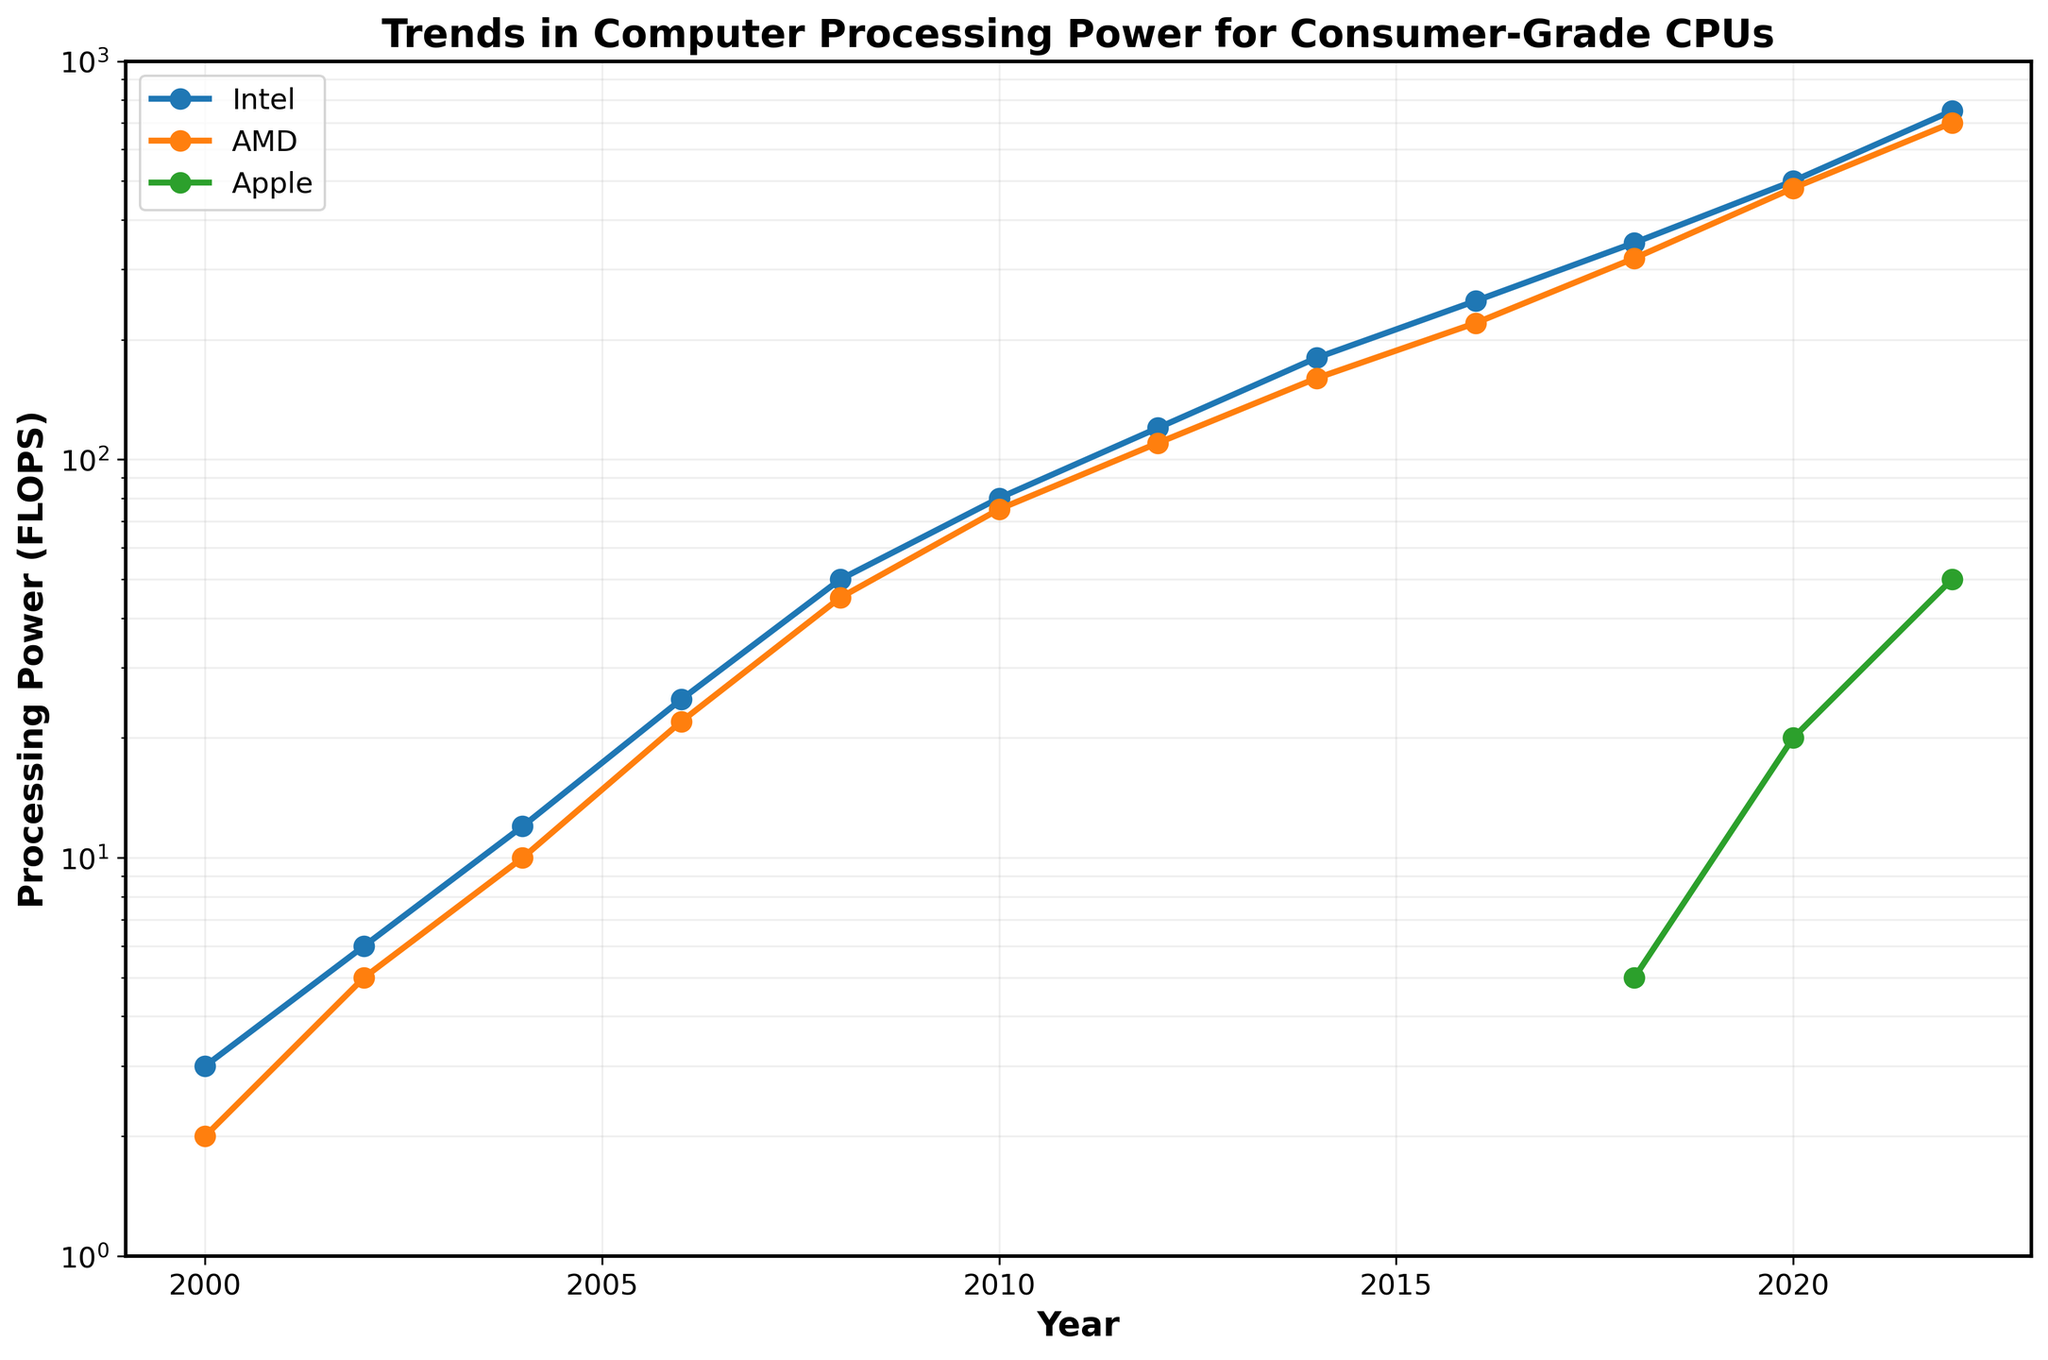What trend can be observed for Intel's processing power from 2000 to 2022? Intel's processing power shows a continuous, exponential increase over the years. Specifically, it starts at 3 FLOPS in 2000 and rises to 750 FLOPS in 2022. This indicates significant advancements in Intel's consumer-grade CPU performance over time.
Answer: Continuous exponential increase When did Apple first appear in the data, and what was its processing power at that time? Apple first appears in the data in 2018, with a processing power of 5 FLOPS. This is seen by looking at the data points plotted for Apple, which start appearing in 2018 on the line chart.
Answer: 2018, 5 FLOPS How does AMD's processing power in 2012 compare to Intel's and Apple's processing power in the same year? In 2012, AMD's processing power is 110 FLOPS, which is slightly lower than Intel's 120 FLOPS. Apple does not have data for 2012 as it only appears in the dataset from 2018 onwards.
Answer: AMD: 110 FLOPS, Intel: 120 FLOPS, Apple: N/A What is the difference in processing power between Intel and AMD in 2020? In 2020, Intel has a processing power of 500 FLOPS and AMD has 480 FLOPS. The difference is calculated by subtracting AMD's value from Intel's value, i.e., 500 - 480 = 20 FLOPS.
Answer: 20 FLOPS Between which years did AMD see the greatest increase in processing power? To find the greatest increase, we calculate the difference for each period. From 2018 to 2020, AMD's processing power increased from 320 to 480 FLOPS, the greatest jump of 160 FLOPS. Checking other years, no other period shows an increase as large as this.
Answer: 2018 to 2020 Compare the growth rate of processing power for Intel and Apple between 2018 and 2022. Intel's processing power grows from 350 FLOPS to 750 FLOPS, an increase of 400 FLOPS. Apple's processing power grows from 5 FLOPS to 50 FLOPS, an increase of 45 FLOPS. Intel's growth in this period is 750/350 ≈ 2.14 times (or approximately 114%), whereas Apple's growth is 50/5 = 10 times (or 900%). Thus, Apple's growth rate is significantly higher.
Answer: Apple's growth rate is significantly higher What does the grid pattern in the plot suggest about the y-axis scaling? The grid lines with varying spacings indicate that the y-axis is plotted on a logarithmic scale, which helps in visualizing exponential growth in processing power clearly and evenly.
Answer: Logarithmic scale Estimate the average processing power of AMD CPUs from 2000 to 2022. Summing AMD's processing powers from each year: 2 + 5 + 10 + 22 + 45 + 75 + 110 + 160 + 220 + 320 + 480 + 700 = 2149; dividing by the number of data points: 2149 / 12 ≈ 179 FLOPS.
Answer: Approximately 179 FLOPS In which year did Intel's processing power first exceed 100 FLOPS? According to the chart, Intel's processing power first exceeded 100 FLOPS in the year 2012, with a value of 120 FLOPS. This is determined by looking at the plotted points for Intel.
Answer: 2012 Considering the visualization, describe the visual difference between Intel and AMD processing power in 2008. In 2008, Intel's processing power is represented as a point slightly higher than AMD's on the chart, showing Intel at 50 FLOPS and AMD at 45 FLOPS. The markers are close but there is a small visual gap between them, indicating that Intel's processing power is higher by 5 FLOPS.
Answer: Intel's processing power is visually higher by a small margin 